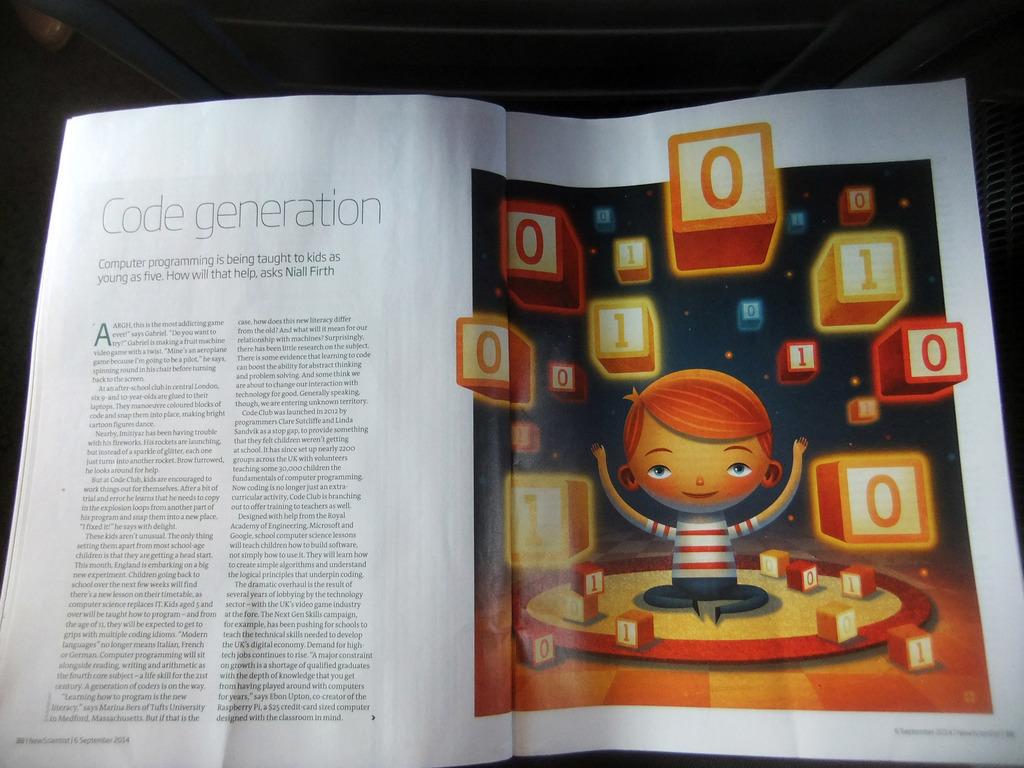Are there ones and zeros in the blocks?
Give a very brief answer. Yes. 